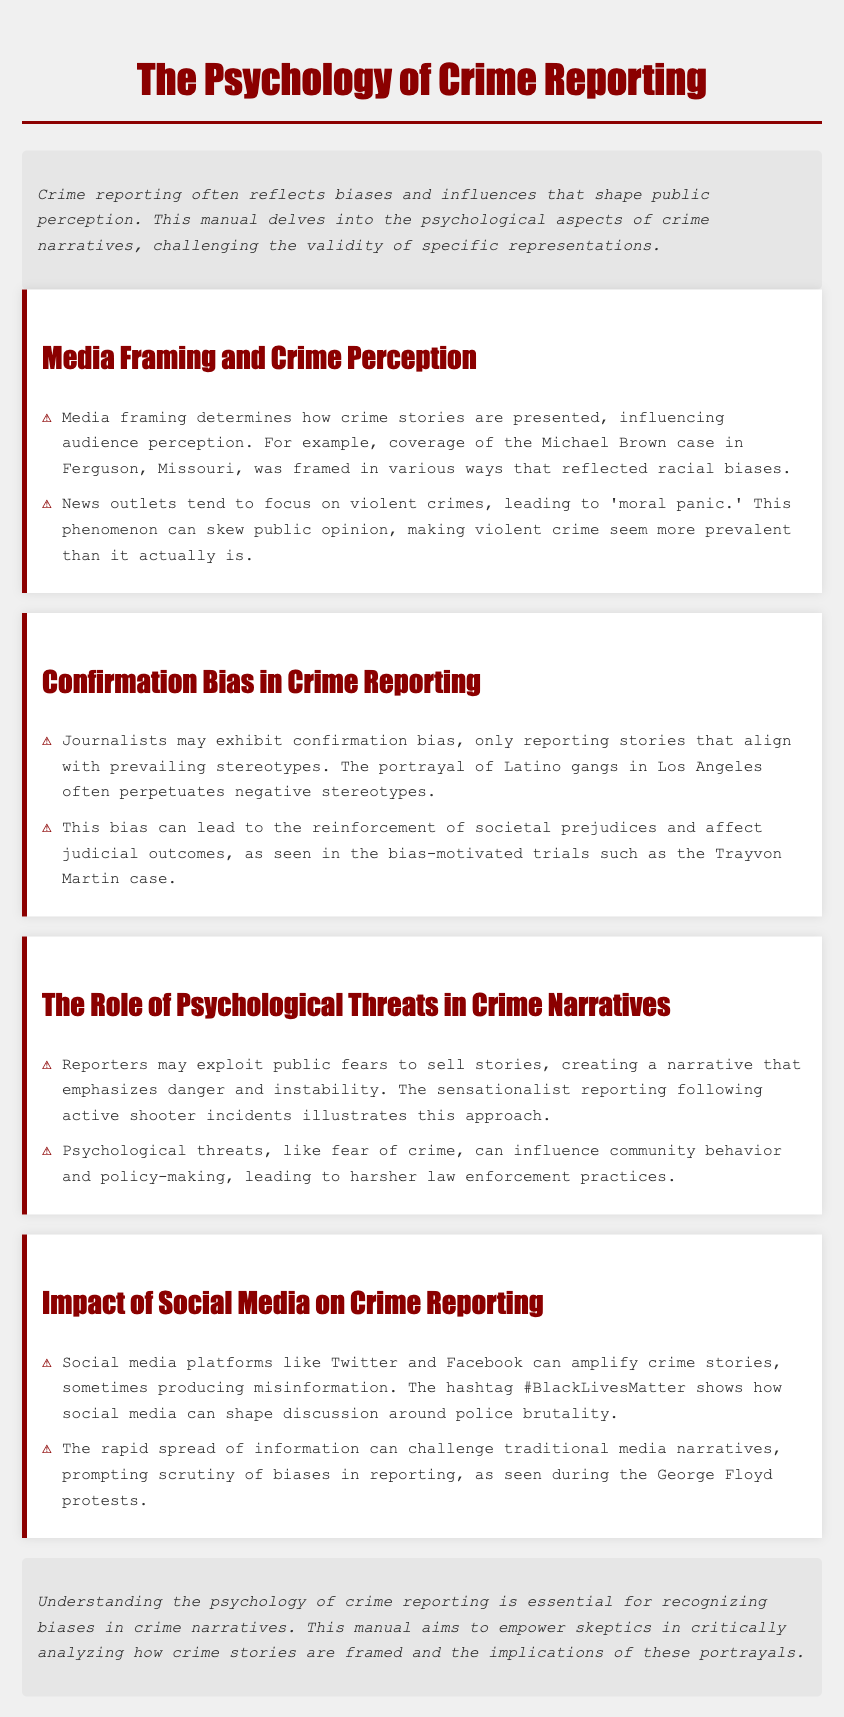What is the title of the manual? The title is indicated at the top of the document in large font, stating the focus of the content.
Answer: The Psychology of Crime Reporting What case is mentioned in relation to media framing? This case is provided as an example to illustrate how media framing can influence perceptions of crime.
Answer: Michael Brown What psychological phenomenon is associated with the disproportionate focus on violent crime in media? The manual describes this phenomenon as contributing to skewed public perception regarding crime levels.
Answer: Moral panic Which social media platform is mentioned as amplifying crime stories? The document specifically refers to this platform in the context of its role in shaping crime narratives.
Answer: Twitter What type of bias is often exhibited by journalists in crime reporting? This bias is crucial in understanding how crime stories align with societal stereotypes and prejudices.
Answer: Confirmation bias What does the hashtag #BlackLivesMatter demonstrate in the context of crime reporting? The manual highlights this hashtag as a significant marker for discussions related to specific social issues.
Answer: Police brutality What effect can psychological threats have on community behavior? The manual discusses the consequences of perceived threats on community responses and law enforcement.
Answer: Harsher law enforcement practices What is a key purpose of this manual? The document's intent is outlined in the conclusion, emphasizing its aim to engage readers critically.
Answer: Empower skeptics What element influences the judicial outcomes as mentioned in the manual? This concept is noted to have an effect on legal processes and public attitudes towards certain groups.
Answer: Bias 